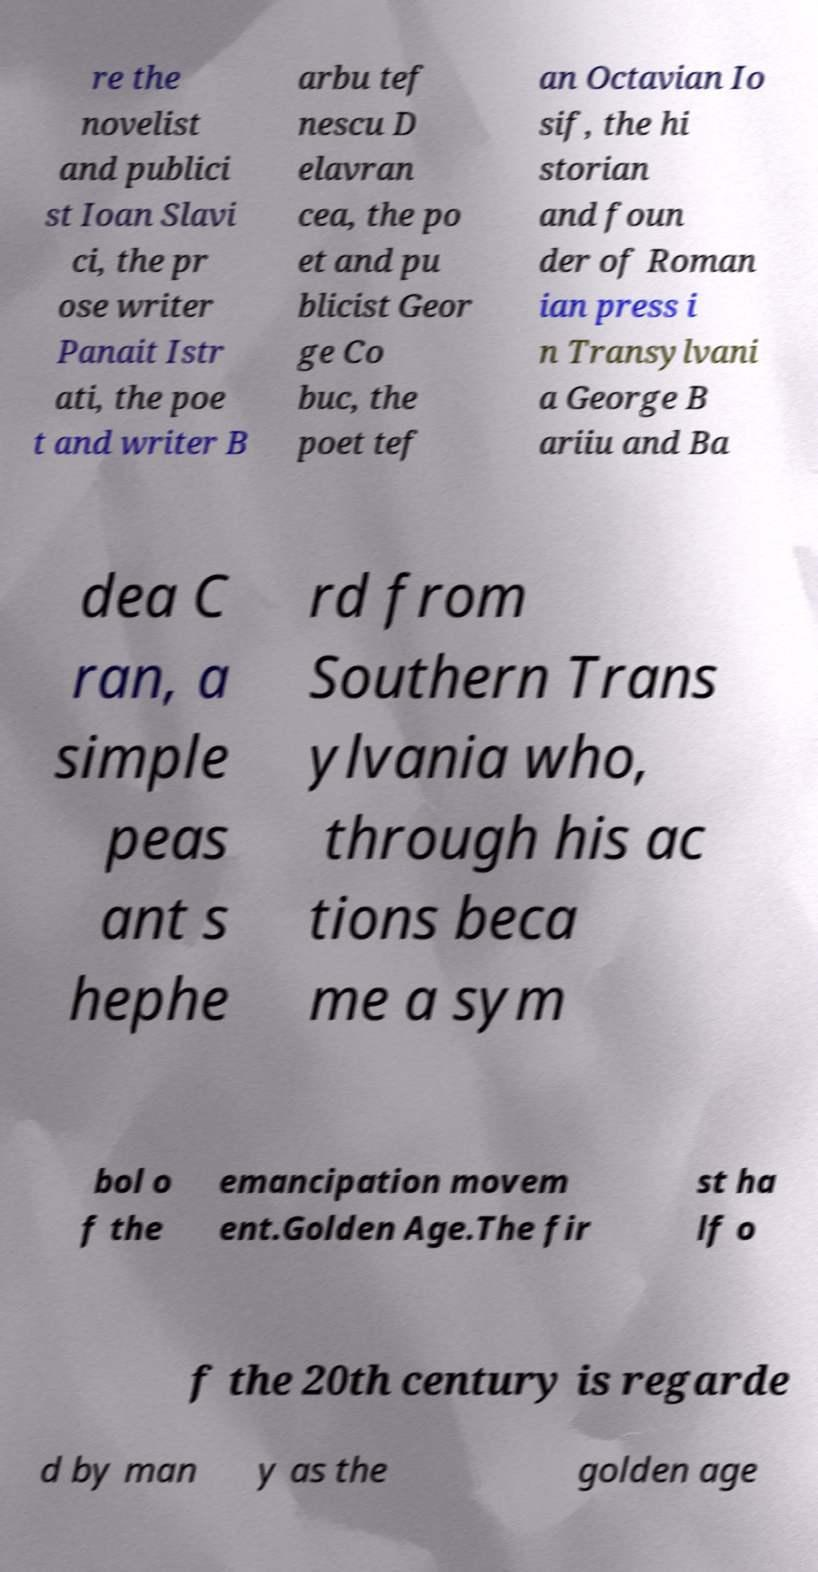Please identify and transcribe the text found in this image. re the novelist and publici st Ioan Slavi ci, the pr ose writer Panait Istr ati, the poe t and writer B arbu tef nescu D elavran cea, the po et and pu blicist Geor ge Co buc, the poet tef an Octavian Io sif, the hi storian and foun der of Roman ian press i n Transylvani a George B ariiu and Ba dea C ran, a simple peas ant s hephe rd from Southern Trans ylvania who, through his ac tions beca me a sym bol o f the emancipation movem ent.Golden Age.The fir st ha lf o f the 20th century is regarde d by man y as the golden age 